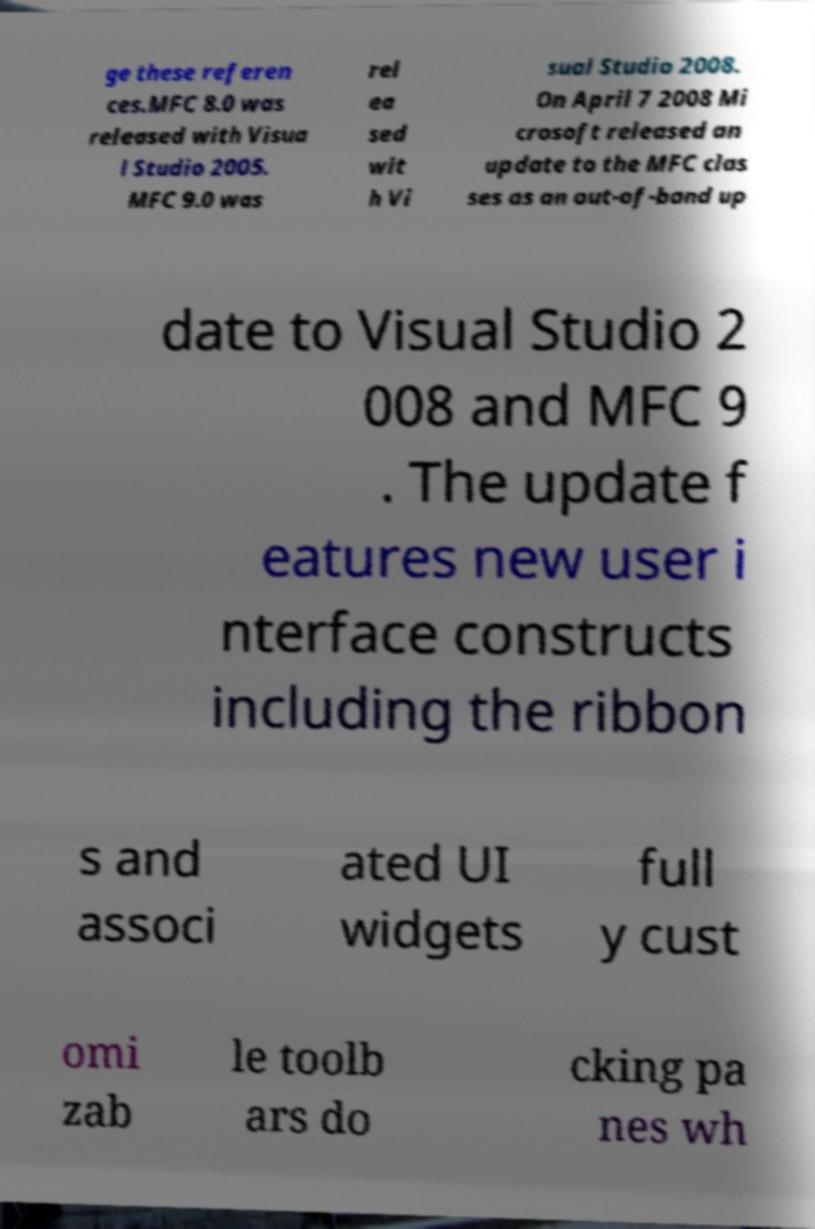What messages or text are displayed in this image? I need them in a readable, typed format. ge these referen ces.MFC 8.0 was released with Visua l Studio 2005. MFC 9.0 was rel ea sed wit h Vi sual Studio 2008. On April 7 2008 Mi crosoft released an update to the MFC clas ses as an out-of-band up date to Visual Studio 2 008 and MFC 9 . The update f eatures new user i nterface constructs including the ribbon s and associ ated UI widgets full y cust omi zab le toolb ars do cking pa nes wh 